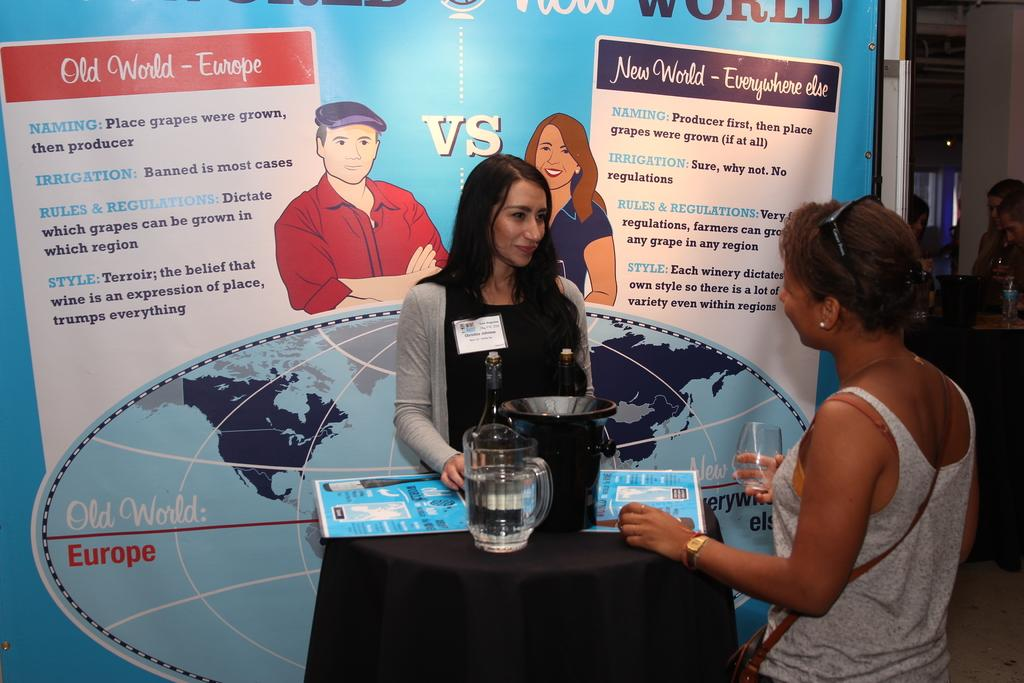How many women are present in the image? There are women standing in the image. What is one of the women holding in her hand? There is a woman holding a glass in her hand. What can be seen on the table in the image? There is a water jar and other objects on the table. What is visible in the background of the image? There is a banner visible in the background. What type of hole can be seen in the image? There is no hole present in the image. What prose is being recited by the women in the image? There is no indication in the image that the women are reciting any prose. 